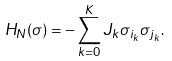Convert formula to latex. <formula><loc_0><loc_0><loc_500><loc_500>H _ { N } ( \sigma ) = - \sum _ { k = 0 } ^ { K } J _ { k } \sigma _ { i _ { k } } \sigma _ { j _ { k } } .</formula> 